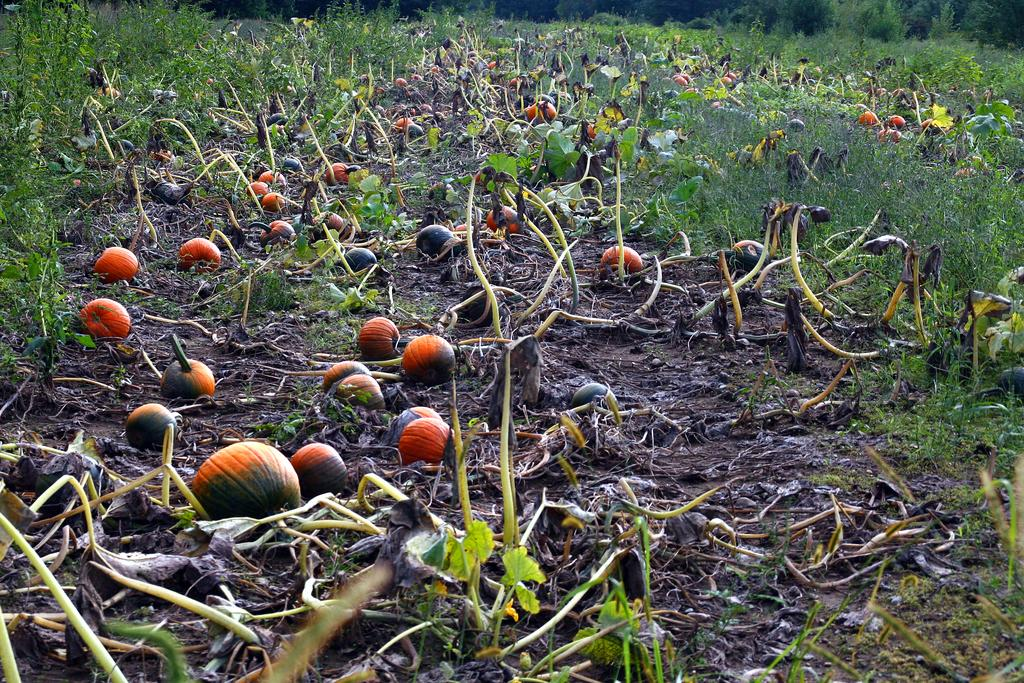What type of vegetation is present in the image? There are pumpkins in the image. What is the ground made of in the image? There is grass on the ground in the image. What type of faucet can be seen in the image? There is no faucet present in the image. 